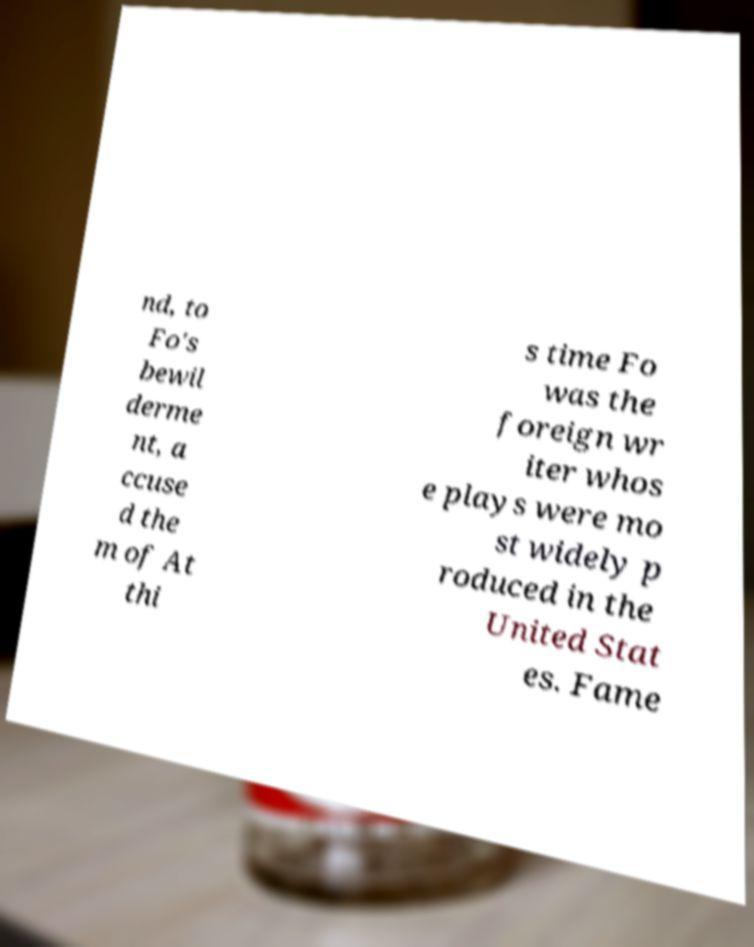For documentation purposes, I need the text within this image transcribed. Could you provide that? nd, to Fo's bewil derme nt, a ccuse d the m of At thi s time Fo was the foreign wr iter whos e plays were mo st widely p roduced in the United Stat es. Fame 